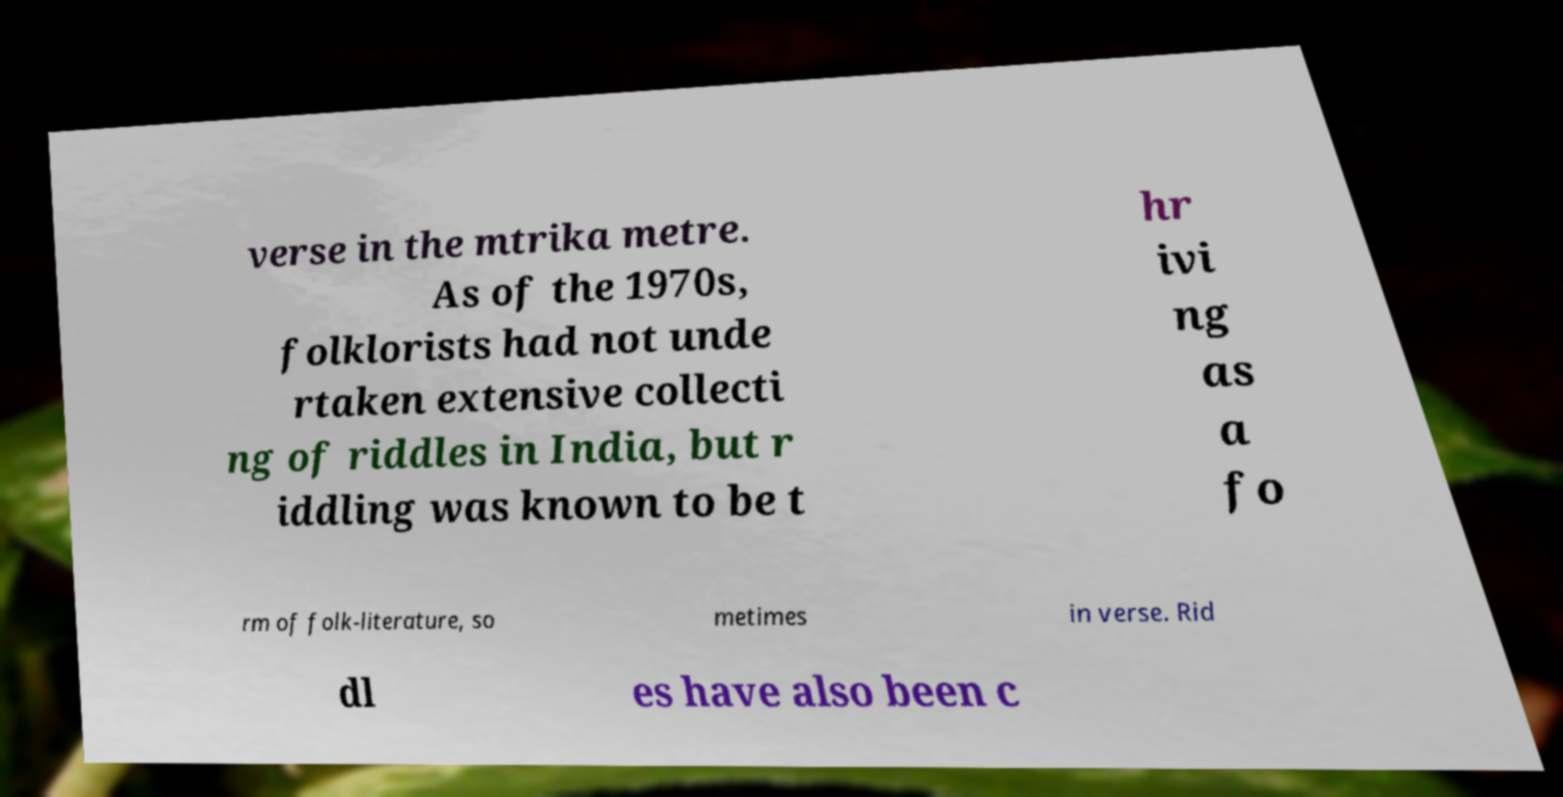Could you extract and type out the text from this image? verse in the mtrika metre. As of the 1970s, folklorists had not unde rtaken extensive collecti ng of riddles in India, but r iddling was known to be t hr ivi ng as a fo rm of folk-literature, so metimes in verse. Rid dl es have also been c 